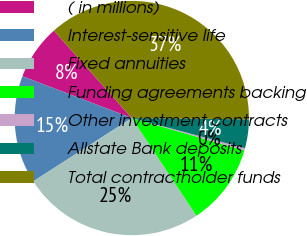<chart> <loc_0><loc_0><loc_500><loc_500><pie_chart><fcel>( in millions)<fcel>Interest-sensitive life<fcel>Fixed annuities<fcel>Funding agreements backing<fcel>Other investment contracts<fcel>Allstate Bank deposits<fcel>Total contractholder funds<nl><fcel>7.61%<fcel>14.89%<fcel>25.21%<fcel>11.25%<fcel>0.32%<fcel>3.96%<fcel>36.75%<nl></chart> 